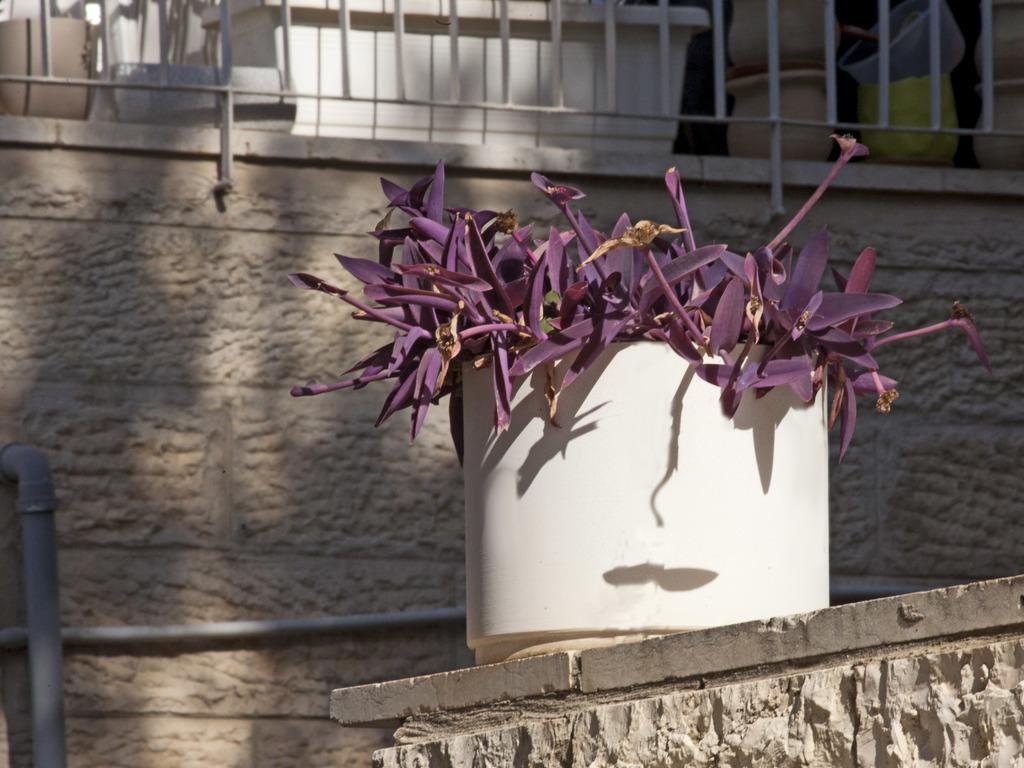In one or two sentences, can you explain what this image depicts? At the bottom of the picture, we see a wall on which a flower pot is placed. In the background, we see a pipe, railing and a wall. At the top, we see the pots and an object in white color. 